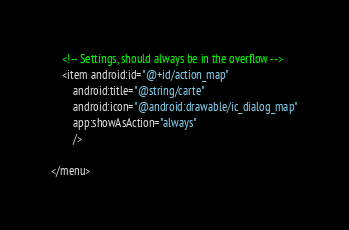Convert code to text. <code><loc_0><loc_0><loc_500><loc_500><_XML_>
    <!-- Settings, should always be in the overflow -->
    <item android:id="@+id/action_map"
        android:title="@string/carte"
        android:icon="@android:drawable/ic_dialog_map"
        app:showAsAction="always"
        />

</menu></code> 